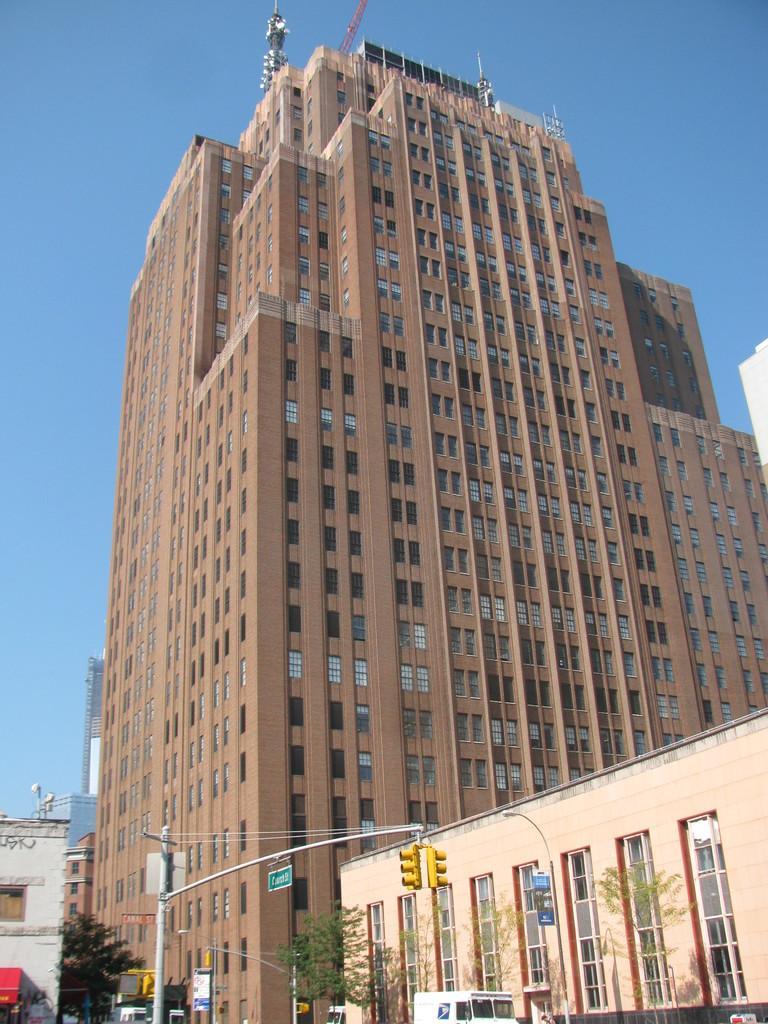Can you describe this image briefly? In this image we can see there are buildings. At the bottom of the image there are few vehicles moving on the road, trees, signal pole. In the background there is a sky. 